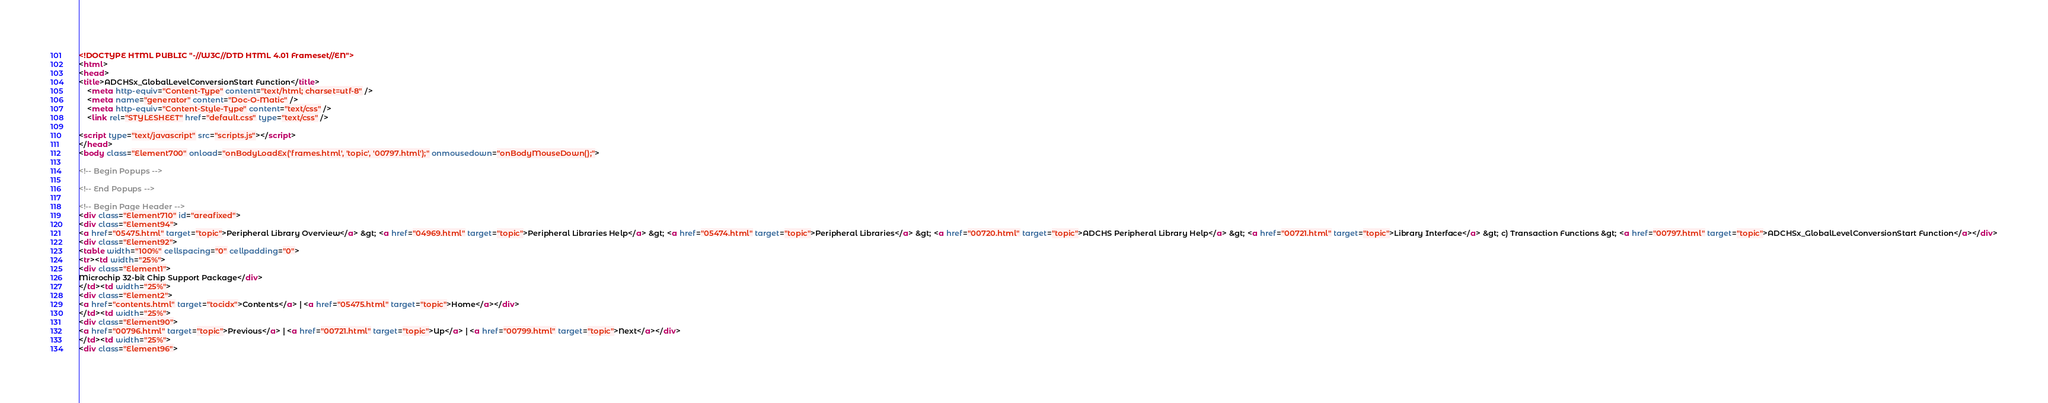Convert code to text. <code><loc_0><loc_0><loc_500><loc_500><_HTML_><!DOCTYPE HTML PUBLIC "-//W3C//DTD HTML 4.01 Frameset//EN">
<html>
<head>
<title>ADCHSx_GlobalLevelConversionStart Function</title>
    <meta http-equiv="Content-Type" content="text/html; charset=utf-8" />
    <meta name="generator" content="Doc-O-Matic" />
    <meta http-equiv="Content-Style-Type" content="text/css" />
    <link rel="STYLESHEET" href="default.css" type="text/css" />

<script type="text/javascript" src="scripts.js"></script>
</head>
<body class="Element700" onload="onBodyLoadEx('frames.html', 'topic', '00797.html');" onmousedown="onBodyMouseDown();">

<!-- Begin Popups -->

<!-- End Popups -->

<!-- Begin Page Header -->
<div class="Element710" id="areafixed">
<div class="Element94">
<a href="05475.html" target="topic">Peripheral Library Overview</a> &gt; <a href="04969.html" target="topic">Peripheral Libraries Help</a> &gt; <a href="05474.html" target="topic">Peripheral Libraries</a> &gt; <a href="00720.html" target="topic">ADCHS Peripheral Library Help</a> &gt; <a href="00721.html" target="topic">Library Interface</a> &gt; c) Transaction Functions &gt; <a href="00797.html" target="topic">ADCHSx_GlobalLevelConversionStart Function</a></div>
<div class="Element92">
<table width="100%" cellspacing="0" cellpadding="0">
<tr><td width="25%">
<div class="Element1">
Microchip 32-bit Chip Support Package</div>
</td><td width="25%">
<div class="Element2">
<a href="contents.html" target="tocidx">Contents</a> | <a href="05475.html" target="topic">Home</a></div>
</td><td width="25%">
<div class="Element90">
<a href="00796.html" target="topic">Previous</a> | <a href="00721.html" target="topic">Up</a> | <a href="00799.html" target="topic">Next</a></div>
</td><td width="25%">
<div class="Element96"></code> 